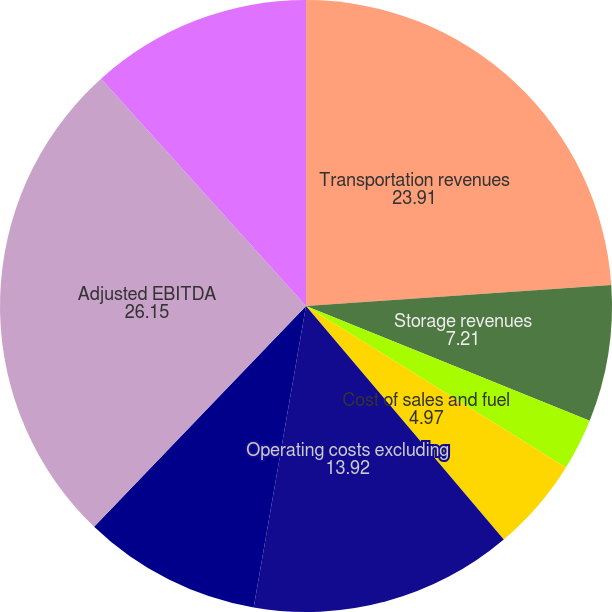Convert chart. <chart><loc_0><loc_0><loc_500><loc_500><pie_chart><fcel>Transportation revenues<fcel>Storage revenues<fcel>Natural gas sales and other<fcel>Cost of sales and fuel<fcel>Operating costs excluding<fcel>Equity in net earnings from<fcel>Adjusted EBITDA<fcel>Capital expenditures<nl><fcel>23.91%<fcel>7.21%<fcel>2.73%<fcel>4.97%<fcel>13.92%<fcel>9.44%<fcel>26.15%<fcel>11.68%<nl></chart> 